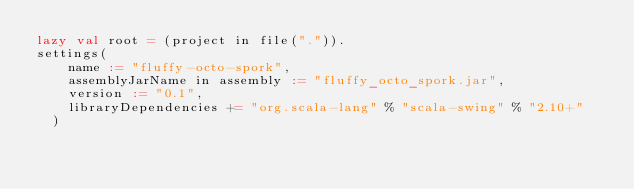Convert code to text. <code><loc_0><loc_0><loc_500><loc_500><_Scala_>lazy val root = (project in file(".")).
settings(
    name := "fluffy-octo-spork",
    assemblyJarName in assembly := "fluffy_octo_spork.jar",
    version := "0.1",
    libraryDependencies += "org.scala-lang" % "scala-swing" % "2.10+"
  )
</code> 